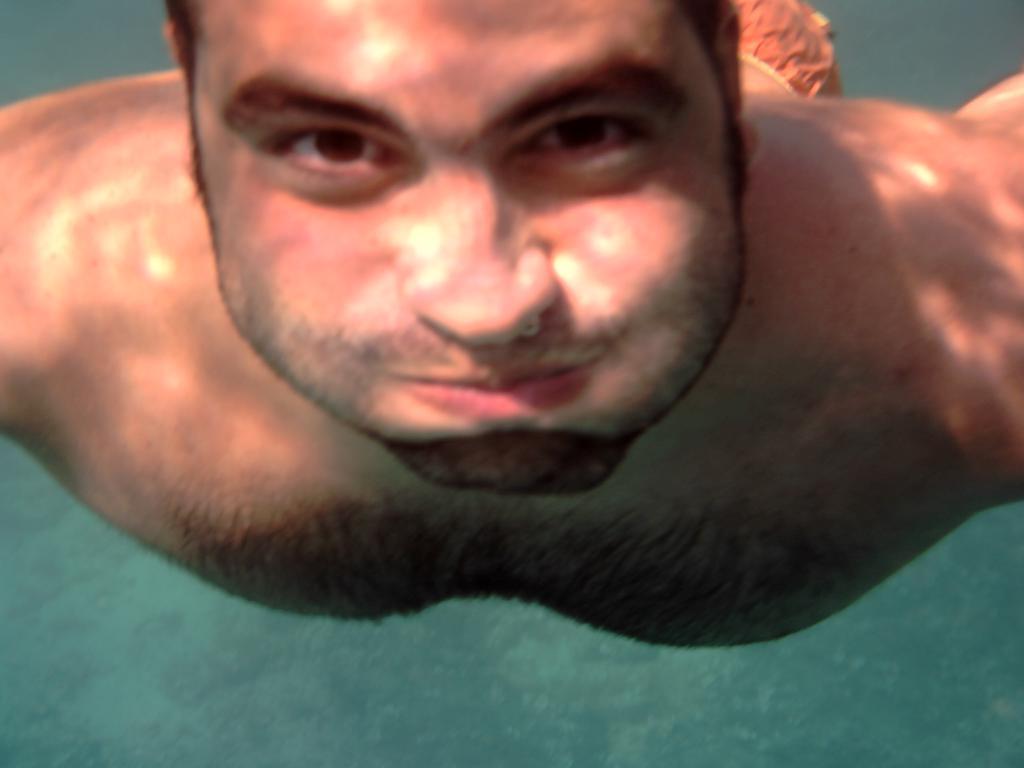In one or two sentences, can you explain what this image depicts? In this image I can see a person inside the water. The water is in green color. 